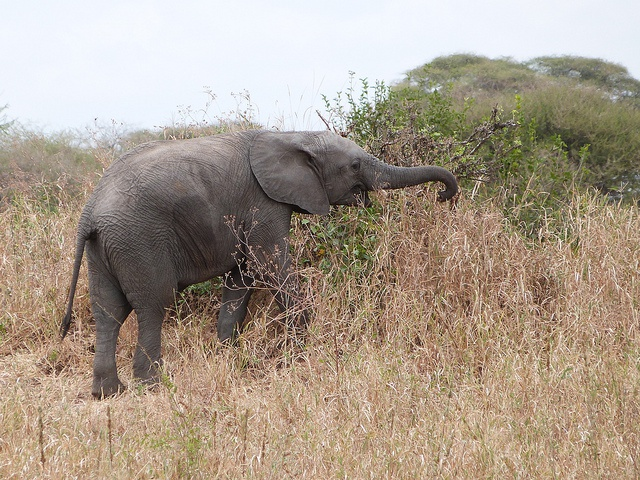Describe the objects in this image and their specific colors. I can see a elephant in white, gray, black, and darkgray tones in this image. 